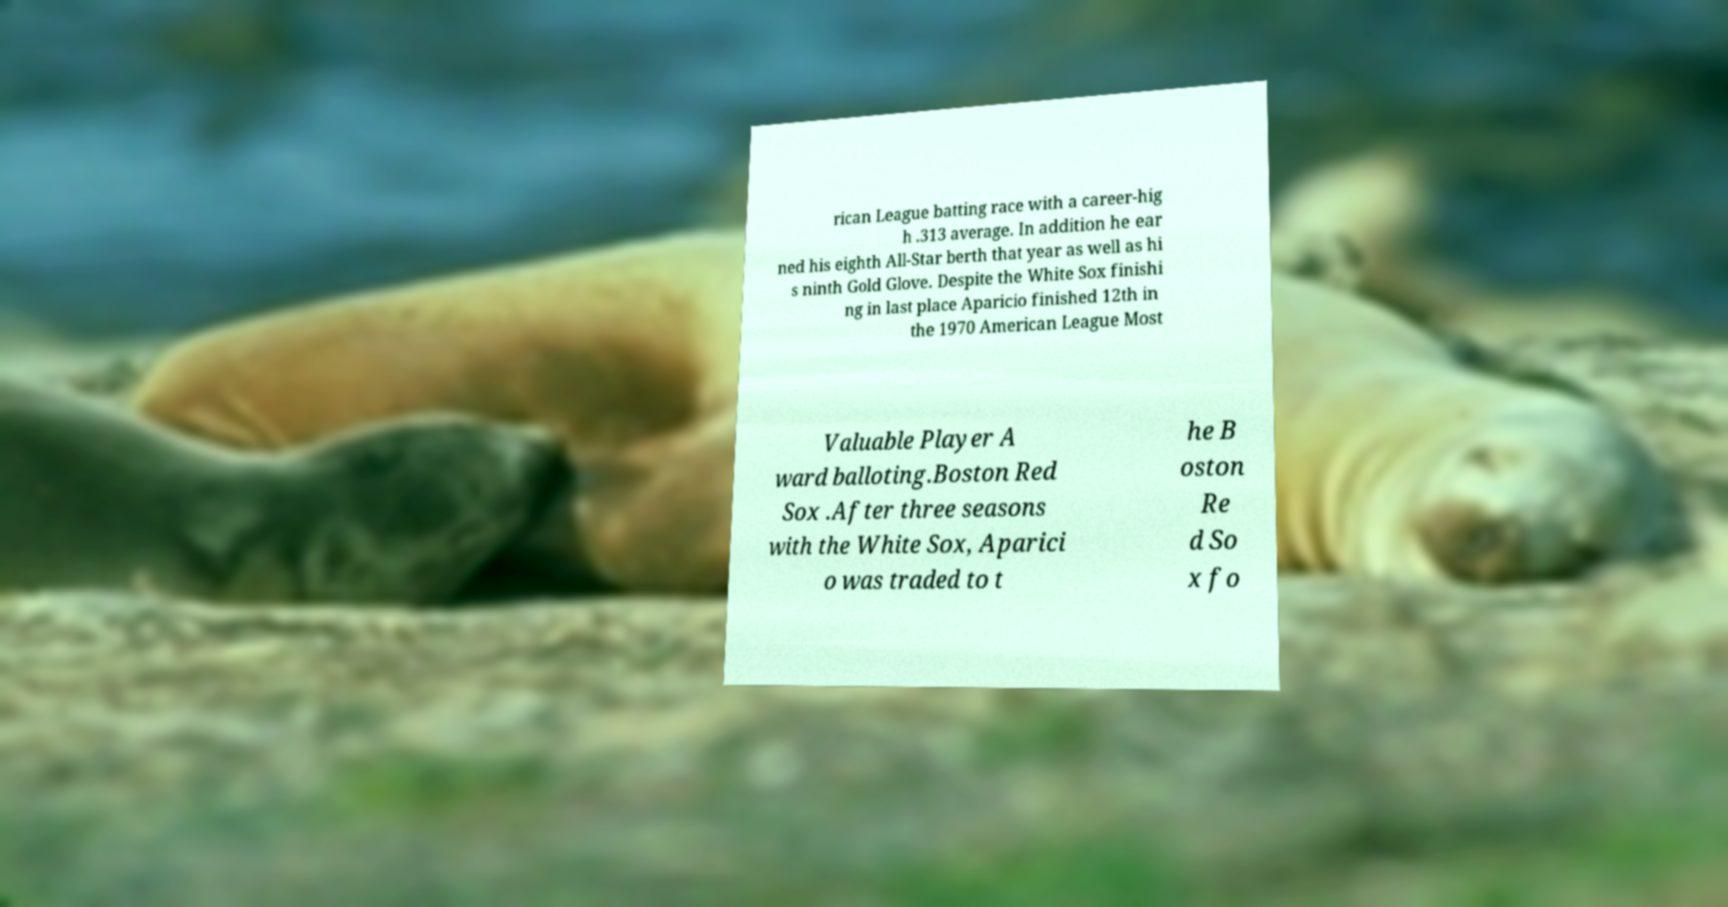Can you read and provide the text displayed in the image?This photo seems to have some interesting text. Can you extract and type it out for me? rican League batting race with a career-hig h .313 average. In addition he ear ned his eighth All-Star berth that year as well as hi s ninth Gold Glove. Despite the White Sox finishi ng in last place Aparicio finished 12th in the 1970 American League Most Valuable Player A ward balloting.Boston Red Sox .After three seasons with the White Sox, Aparici o was traded to t he B oston Re d So x fo 